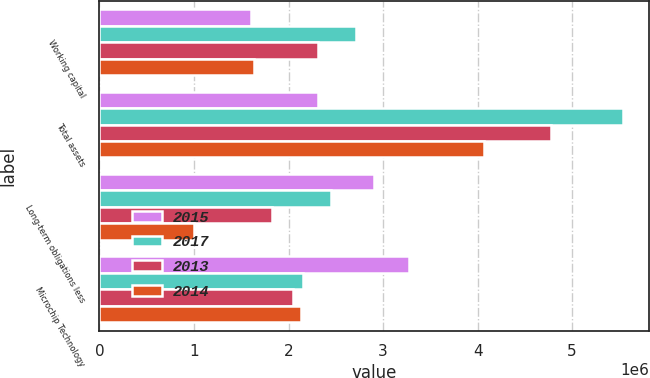Convert chart to OTSL. <chart><loc_0><loc_0><loc_500><loc_500><stacked_bar_chart><ecel><fcel>Working capital<fcel>Total assets<fcel>Long-term obligations less<fcel>Microchip Technology<nl><fcel>2015<fcel>1.60059e+06<fcel>2.31064e+06<fcel>2.90052e+06<fcel>3.27071e+06<nl><fcel>2017<fcel>2.7147e+06<fcel>5.53788e+06<fcel>2.4534e+06<fcel>2.15092e+06<nl><fcel>2013<fcel>2.31064e+06<fcel>4.78071e+06<fcel>1.82686e+06<fcel>2.04465e+06<nl><fcel>2014<fcel>1.63332e+06<fcel>4.06763e+06<fcel>1.00326e+06<fcel>2.13546e+06<nl></chart> 